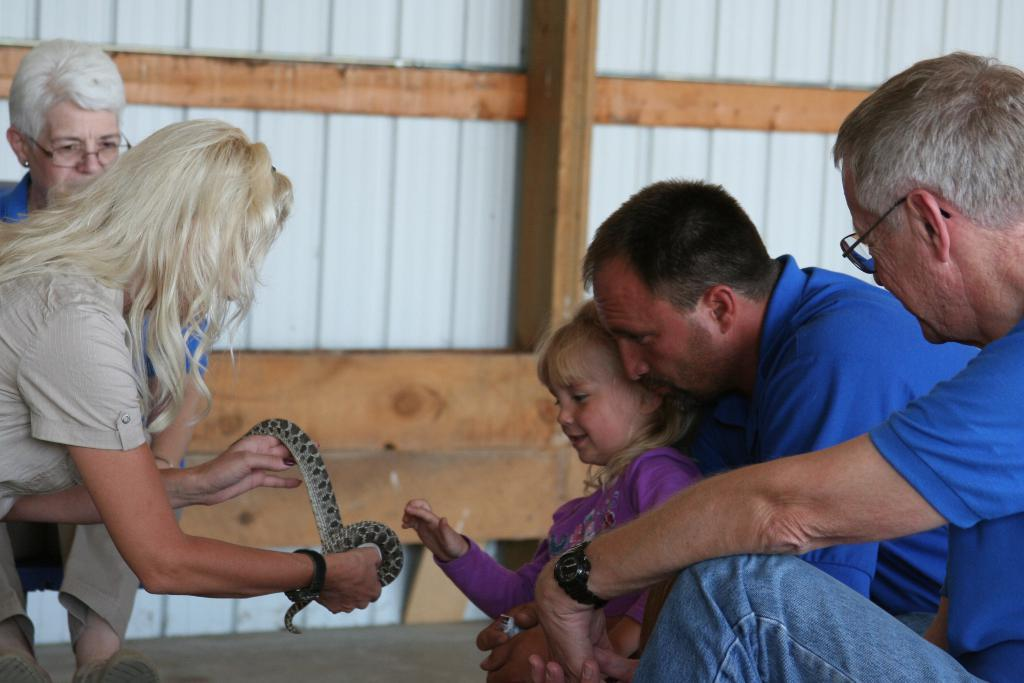What is the woman holding in the image? The woman is holding a snake in the image. What is the woman doing with the snake? The woman is showing the snake to a girl. What is the girl's reaction to the snake? The girl is about to touch the snake. Who else is present in the image? There are two men beside the girl and another woman in the background. What type of food is the girl eating in the image? There is no food present in the image; the girl is about to touch a snake. What educational institution is the woman representing in the image? There is no indication of an educational institution in the image; the woman is simply holding a snake. 